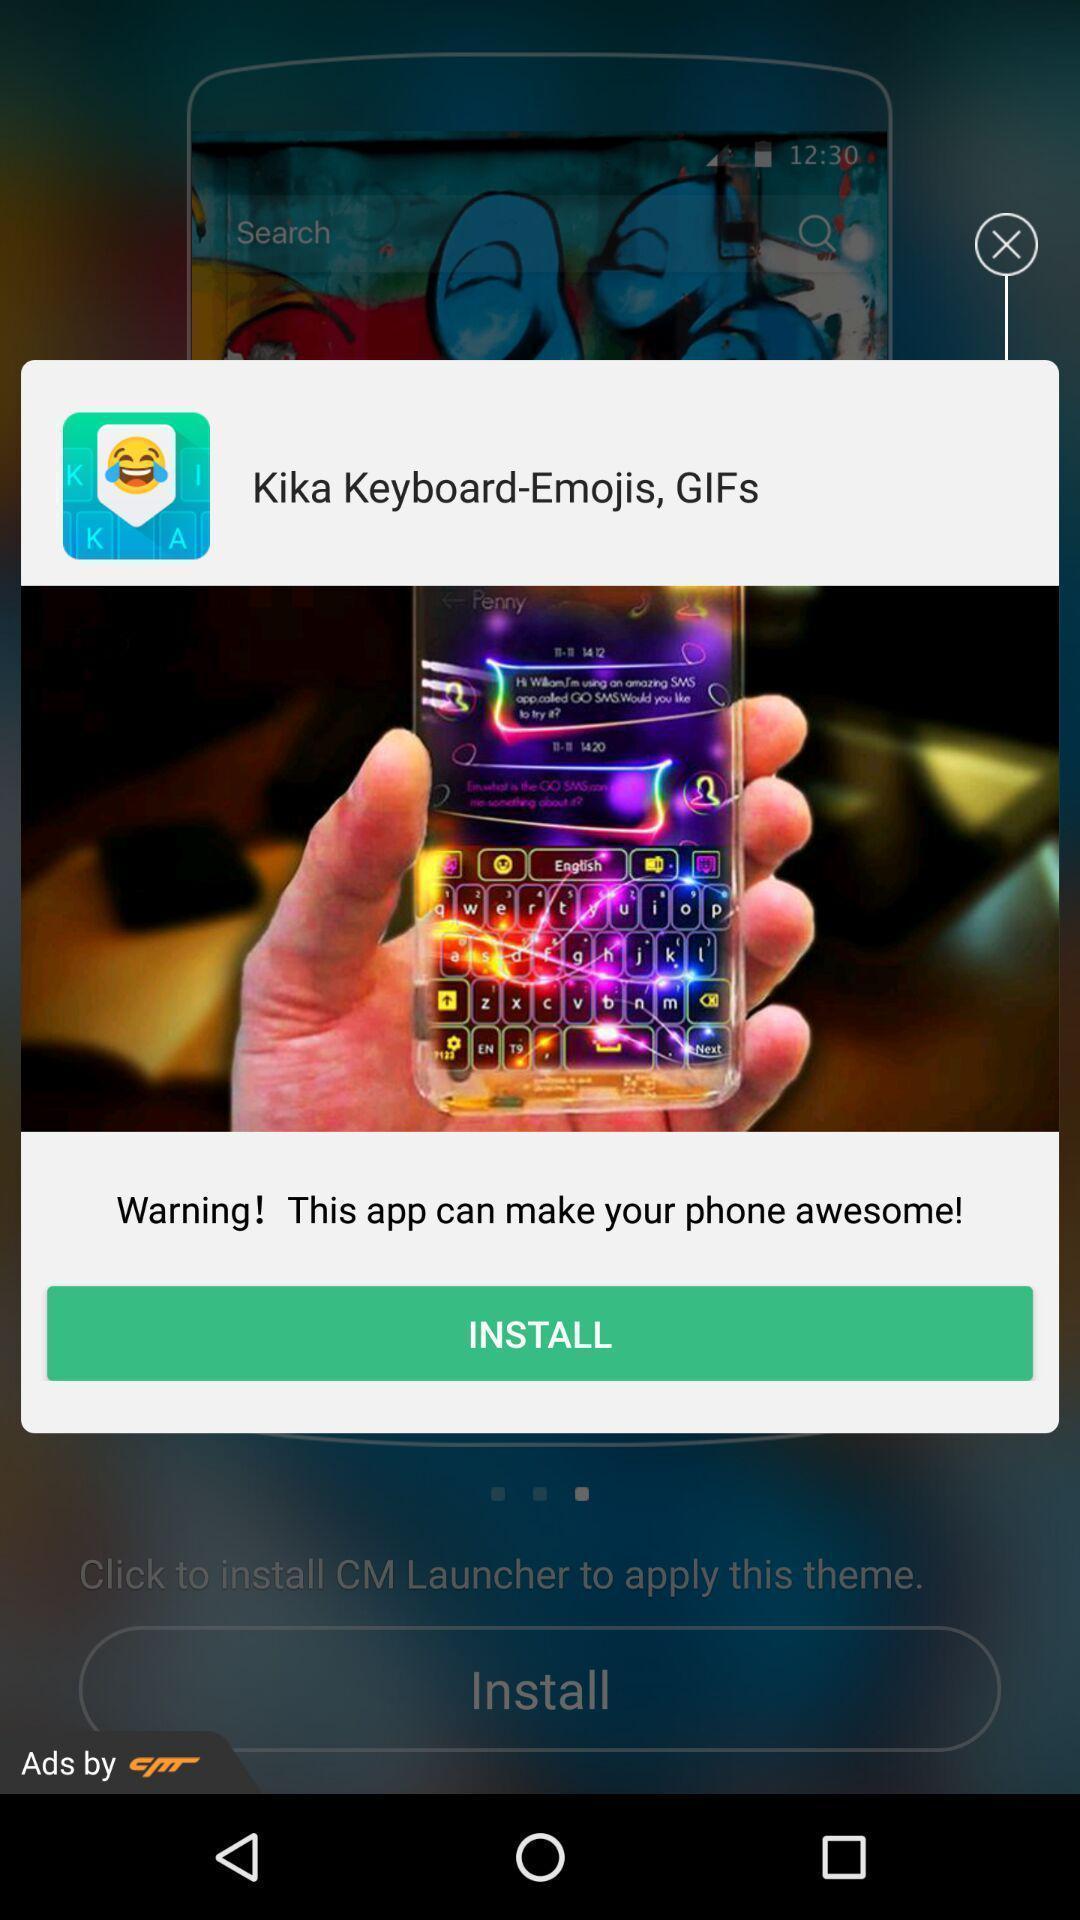Describe the content in this image. Popup displaying warning information about installation. 